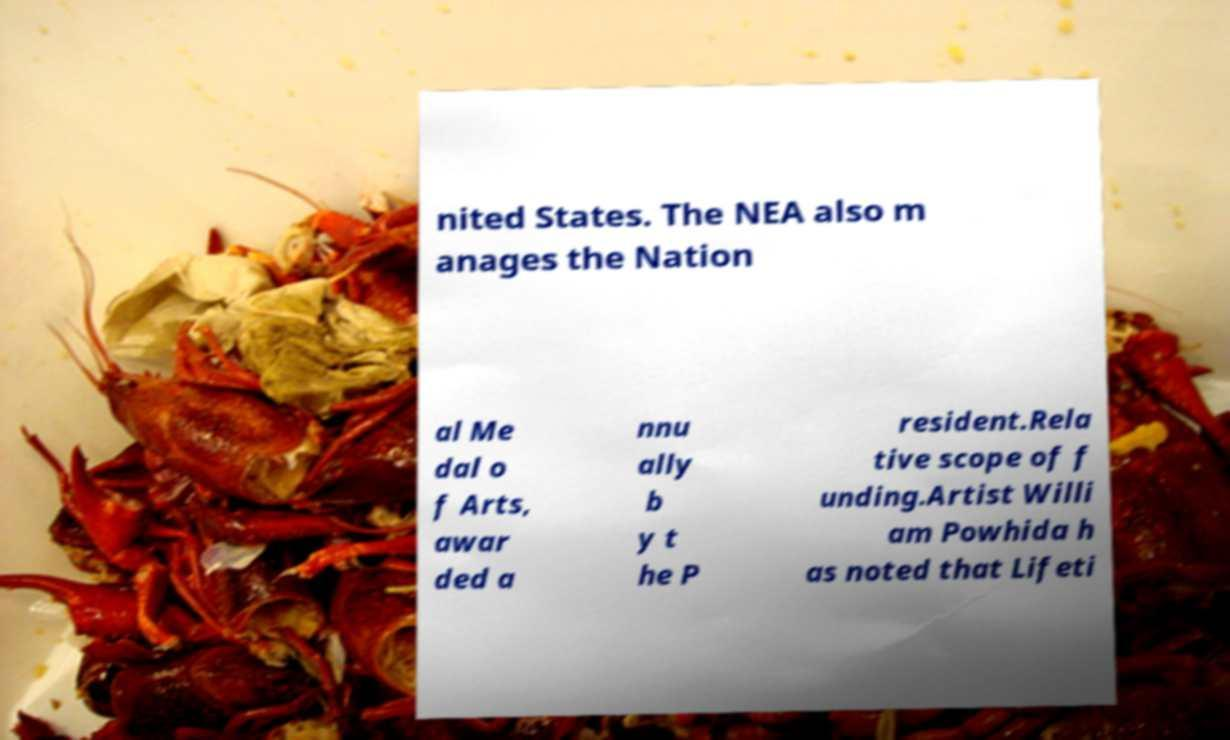Could you assist in decoding the text presented in this image and type it out clearly? nited States. The NEA also m anages the Nation al Me dal o f Arts, awar ded a nnu ally b y t he P resident.Rela tive scope of f unding.Artist Willi am Powhida h as noted that Lifeti 